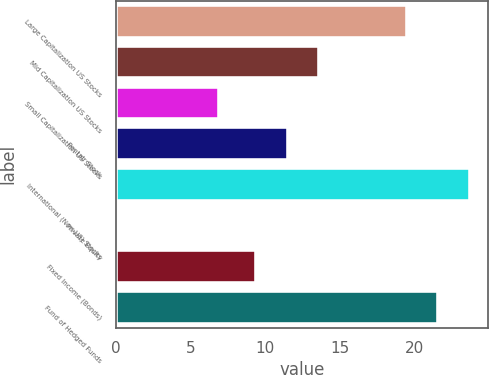Convert chart. <chart><loc_0><loc_0><loc_500><loc_500><bar_chart><fcel>Large Capitalization US Stocks<fcel>Mid Capitalization US Stocks<fcel>Small Capitalization US Stocks<fcel>Pentair Stock<fcel>International (Non-US) Stocks<fcel>Private Equity<fcel>Fixed Income (Bonds)<fcel>Fund of Hedged Funds<nl><fcel>19.5<fcel>13.62<fcel>6.9<fcel>11.51<fcel>23.72<fcel>0.1<fcel>9.4<fcel>21.61<nl></chart> 